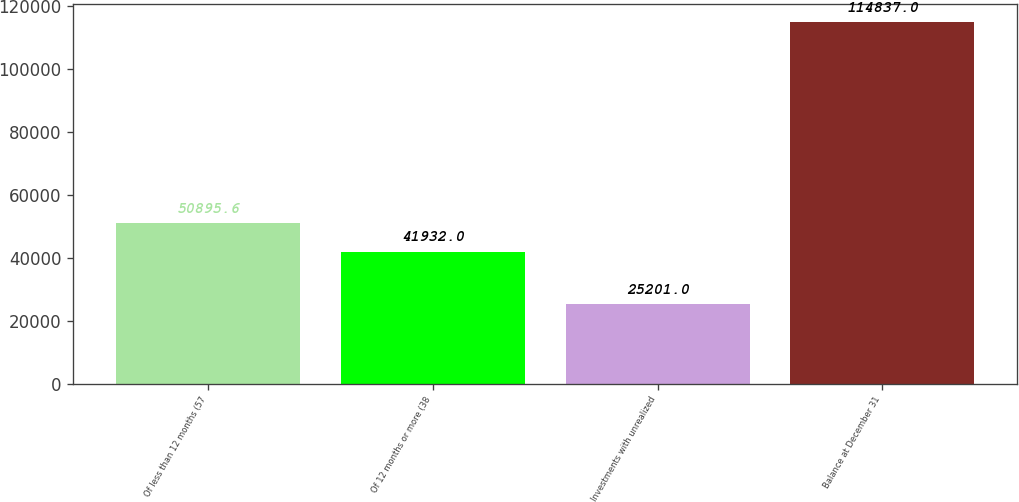Convert chart to OTSL. <chart><loc_0><loc_0><loc_500><loc_500><bar_chart><fcel>Of less than 12 months (57<fcel>Of 12 months or more (38<fcel>Investments with unrealized<fcel>Balance at December 31<nl><fcel>50895.6<fcel>41932<fcel>25201<fcel>114837<nl></chart> 